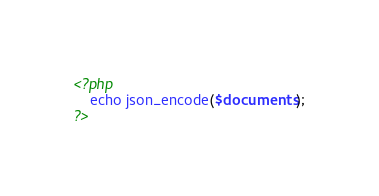Convert code to text. <code><loc_0><loc_0><loc_500><loc_500><_PHP_><?php
	echo json_encode($documents);
?></code> 